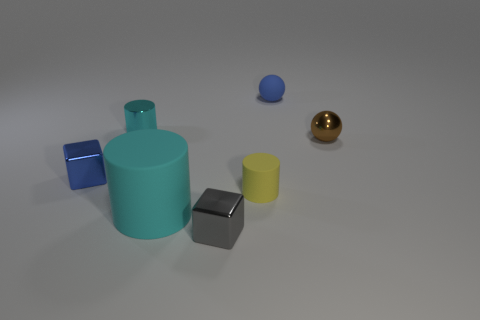How many cyan cylinders must be subtracted to get 1 cyan cylinders? 1 Add 1 tiny blue metal things. How many objects exist? 8 Subtract all cylinders. How many objects are left? 4 Add 4 small rubber cylinders. How many small rubber cylinders are left? 5 Add 1 small yellow rubber objects. How many small yellow rubber objects exist? 2 Subtract 1 gray blocks. How many objects are left? 6 Subtract all tiny blue cubes. Subtract all cyan cylinders. How many objects are left? 4 